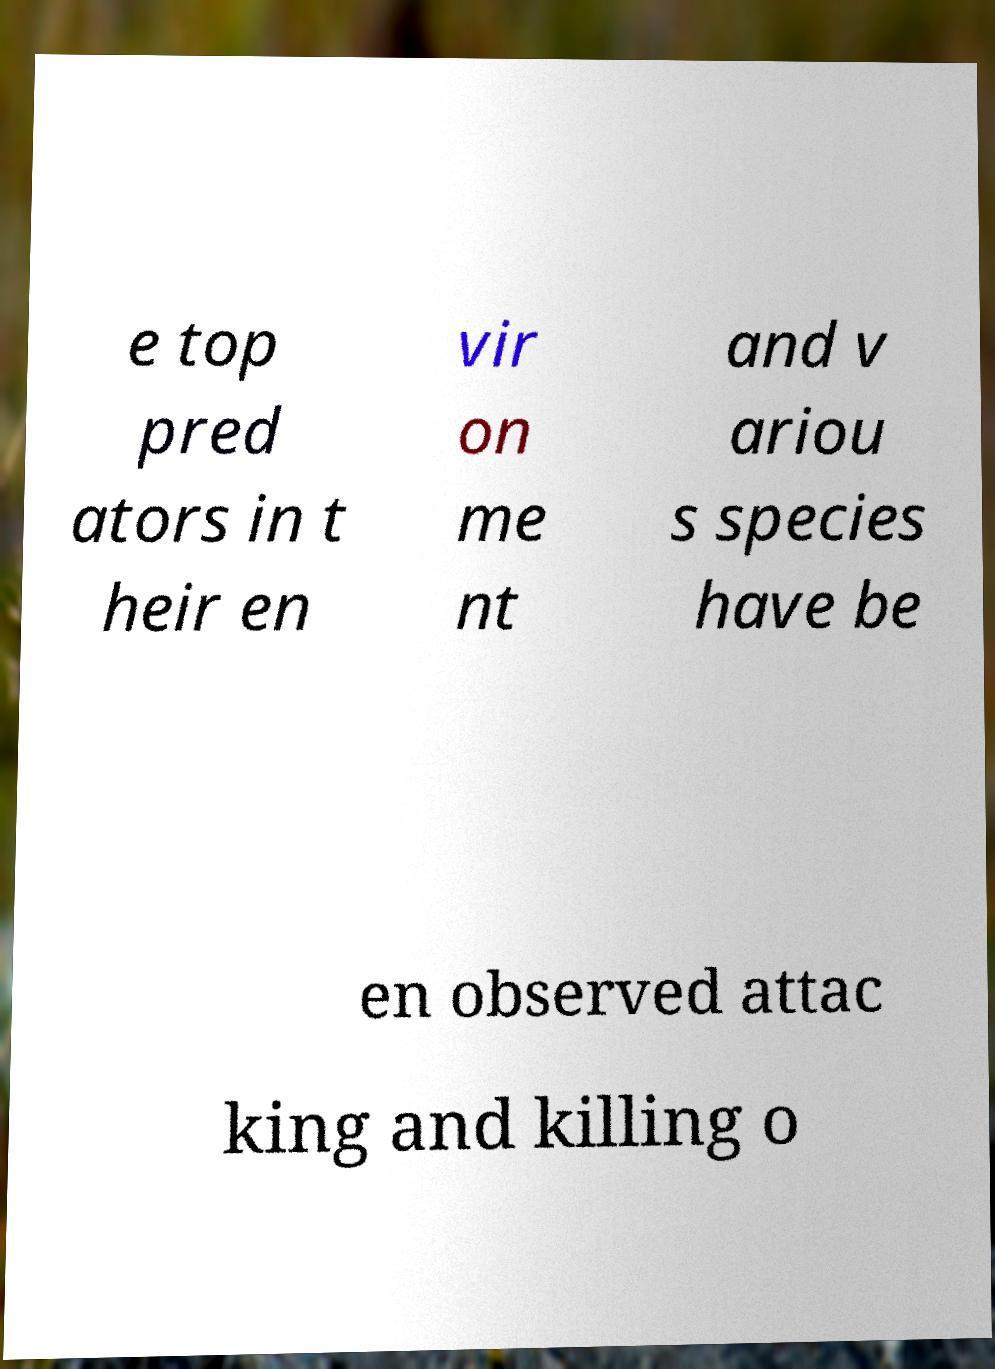What messages or text are displayed in this image? I need them in a readable, typed format. e top pred ators in t heir en vir on me nt and v ariou s species have be en observed attac king and killing o 